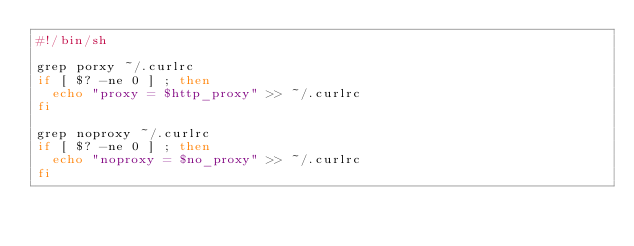Convert code to text. <code><loc_0><loc_0><loc_500><loc_500><_Bash_>#!/bin/sh

grep porxy ~/.curlrc
if [ $? -ne 0 ] ; then
  echo "proxy = $http_proxy" >> ~/.curlrc
fi

grep noproxy ~/.curlrc
if [ $? -ne 0 ] ; then
  echo "noproxy = $no_proxy" >> ~/.curlrc
fi

</code> 